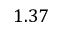Convert formula to latex. <formula><loc_0><loc_0><loc_500><loc_500>1 . 3 7</formula> 